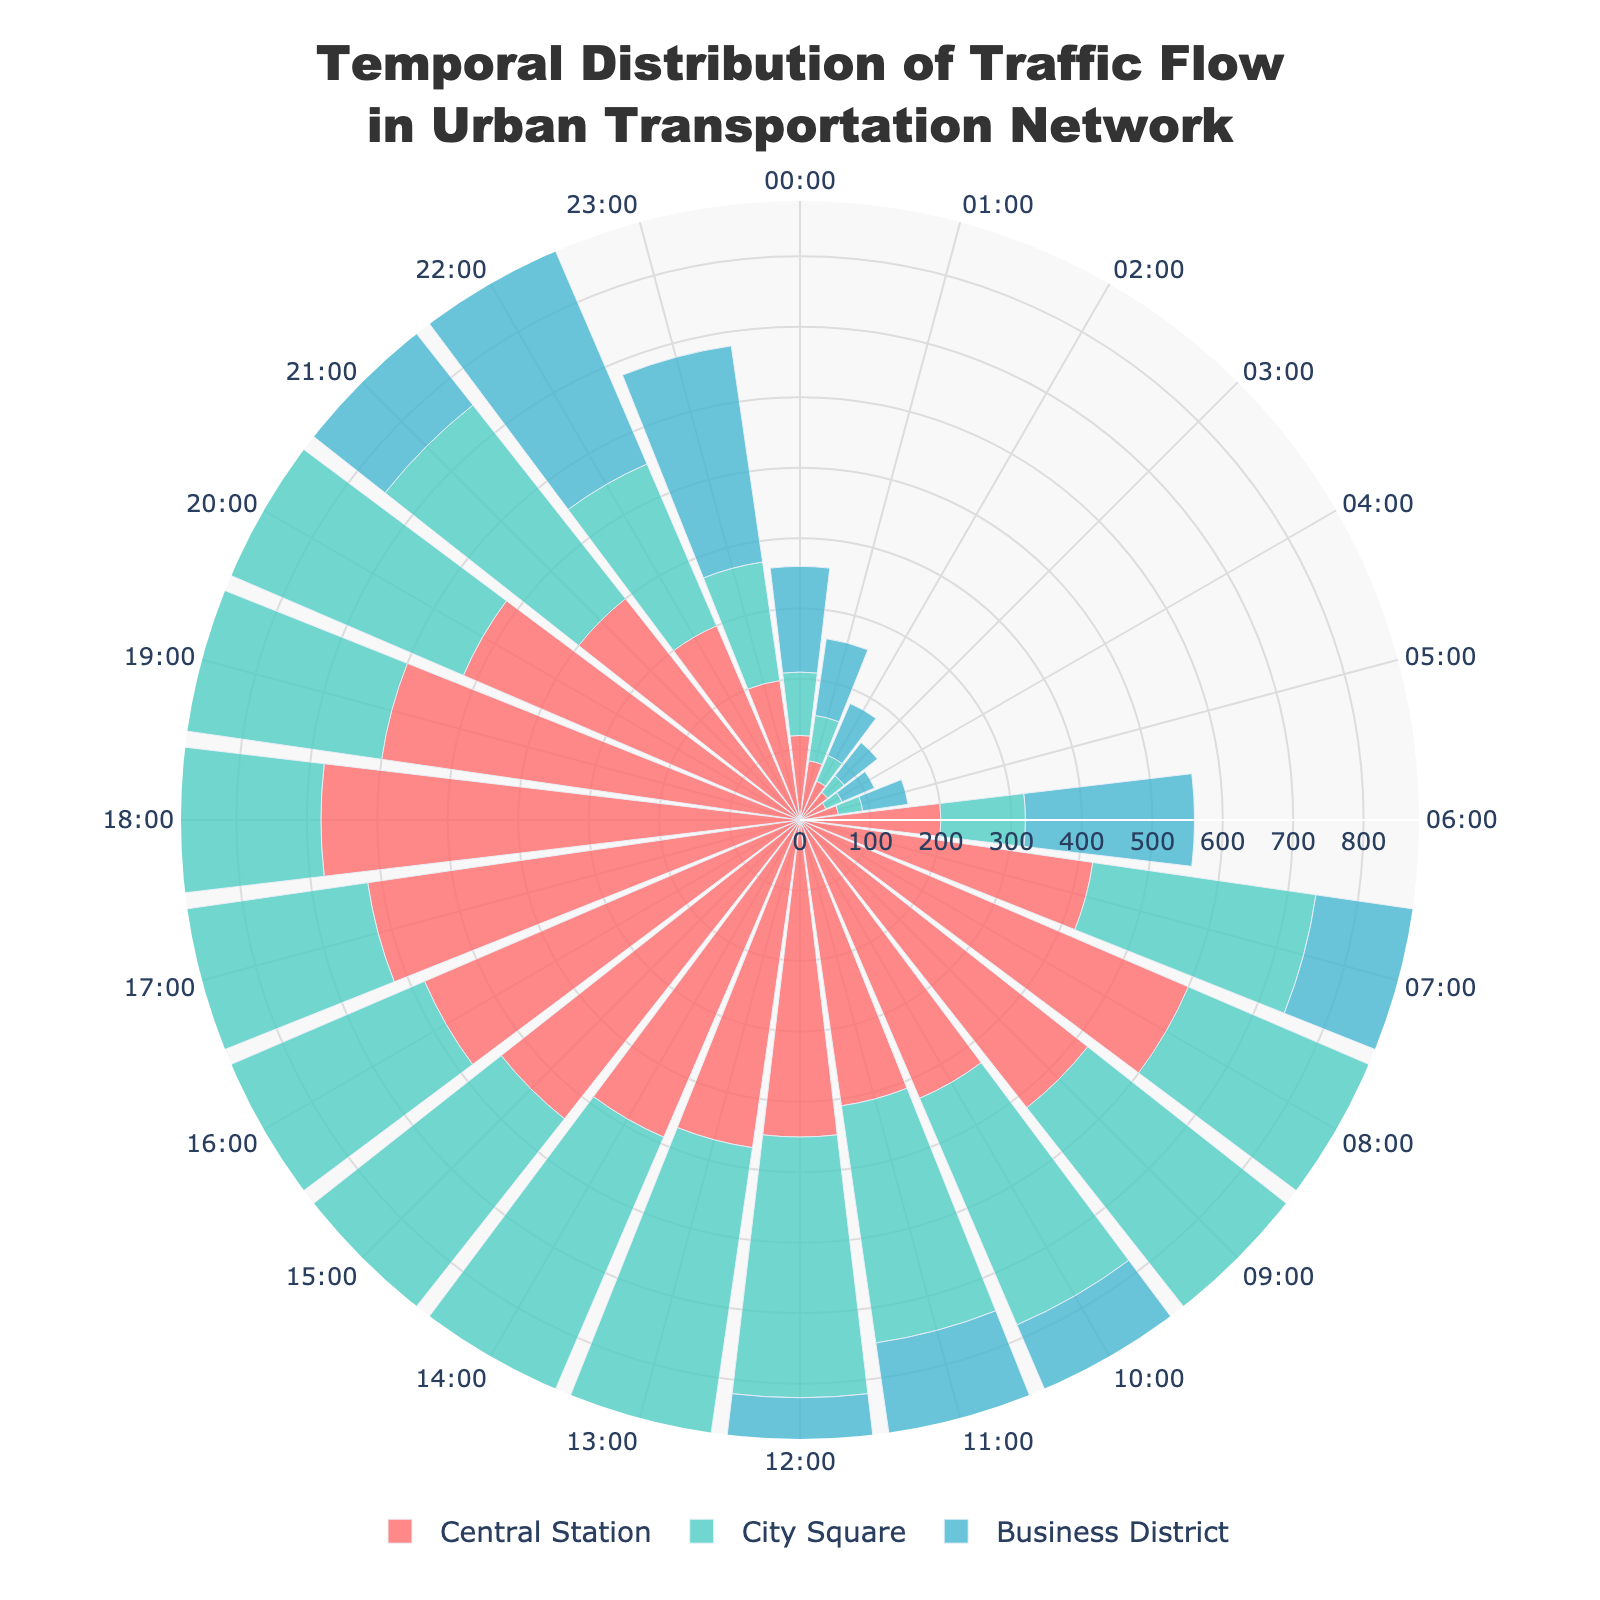What is the title of the figure? The title is located at the top of the chart and is usually the largest text. In this case, it states "Temporal Distribution of Traffic Flow in Urban Transportation Network".
Answer: Temporal Distribution of Traffic Flow in Urban Transportation Network Which group experiences the highest traffic flow at 08:00? At each radial position corresponding to 08:00, examine the different segments representing different groups to find the longest segment. In this case, the Business District shows the highest traffic flow.
Answer: Business District During which time period does City Square experience its maximum traffic flow? Locate the maximum segment for City Square in terms of its radial length, then check the angular position of this segment. The peak value for City Square occurs at 18:00.
Answer: 18:00 What are the traffic flow values for the Central Station at 08:00 and 18:00? Find the segments corresponding to Central Station at 08:00 and 18:00 and read off their lengths. These segments represent traffic flow values. The values are 600 and 680 respectively.
Answer: 600 at 08:00 and 680 at 18:00 Which group shows the least traffic flow overall during the night hours (00:00-06:00)? Sum the traffic flow values for each group between 00:00 and 06:00. The group with the smallest total flow is City Square.
Answer: City Square At what time does the Central Station start seeing a consistent increase in traffic flow? Observe the traffic flow values for Central Station starting from the lowest values and note the point where traffic flow consistently increases. This starts around 06:00.
Answer: 06:00 Compare the traffic flow at City Square and Business District at 17:00. Which one is higher? Identify the radial segments for City Square and Business District at 17:00. By comparing their lengths, the Business District segment is longer.
Answer: Business District What’s the total traffic flow for the Business District from 10:00 to 14:00? Sum the radial lengths representing traffic flow at 10:00, 11:00, 12:00, 13:00, and 14:00 for the Business District. These values are 540, 520, 560, 580, and 600, respectively. The total is 2800.
Answer: 2800 How does the temporal traffic pattern differ between Central Station and Business District? Observe how the radial lengths change over time for both groups. Central Station shows more consistent peaks during morning and evening rush hours while Business District shows consistently high traffic throughout the day.
Answer: Central Station: peaks in the morning and evening; Business District: consistently high 